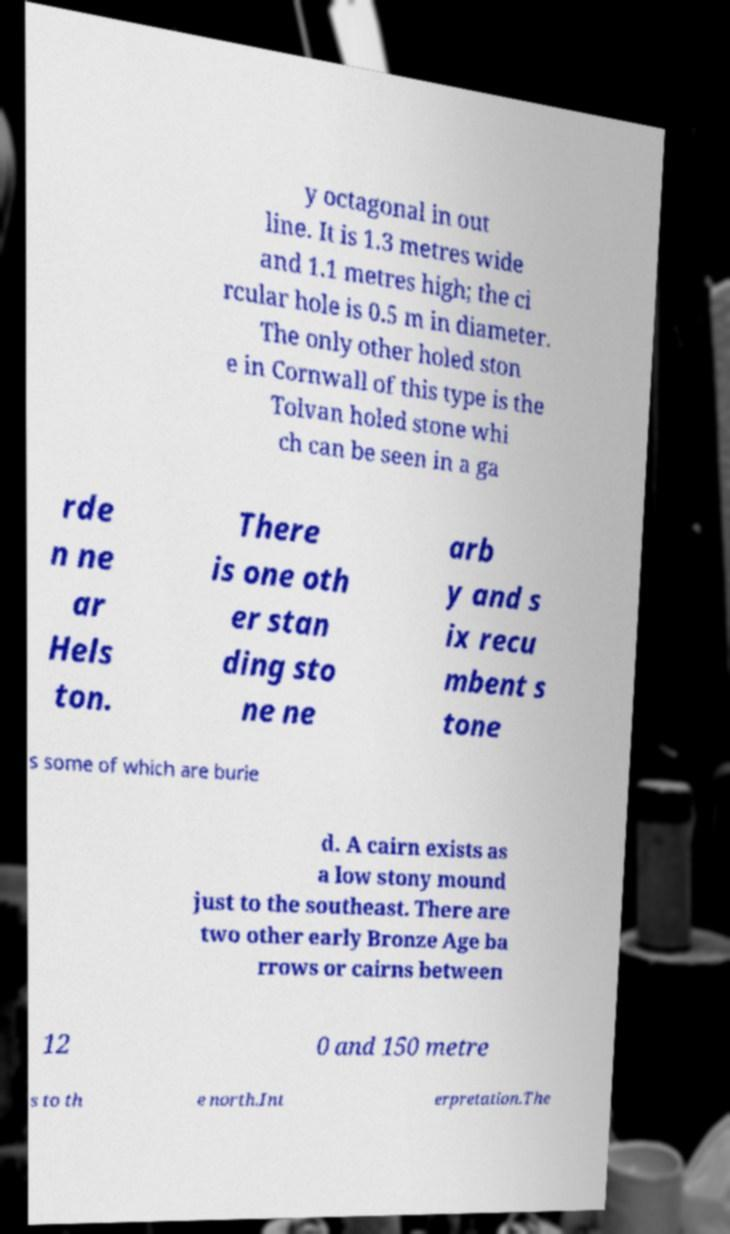Please read and relay the text visible in this image. What does it say? y octagonal in out line. It is 1.3 metres wide and 1.1 metres high; the ci rcular hole is 0.5 m in diameter. The only other holed ston e in Cornwall of this type is the Tolvan holed stone whi ch can be seen in a ga rde n ne ar Hels ton. There is one oth er stan ding sto ne ne arb y and s ix recu mbent s tone s some of which are burie d. A cairn exists as a low stony mound just to the southeast. There are two other early Bronze Age ba rrows or cairns between 12 0 and 150 metre s to th e north.Int erpretation.The 